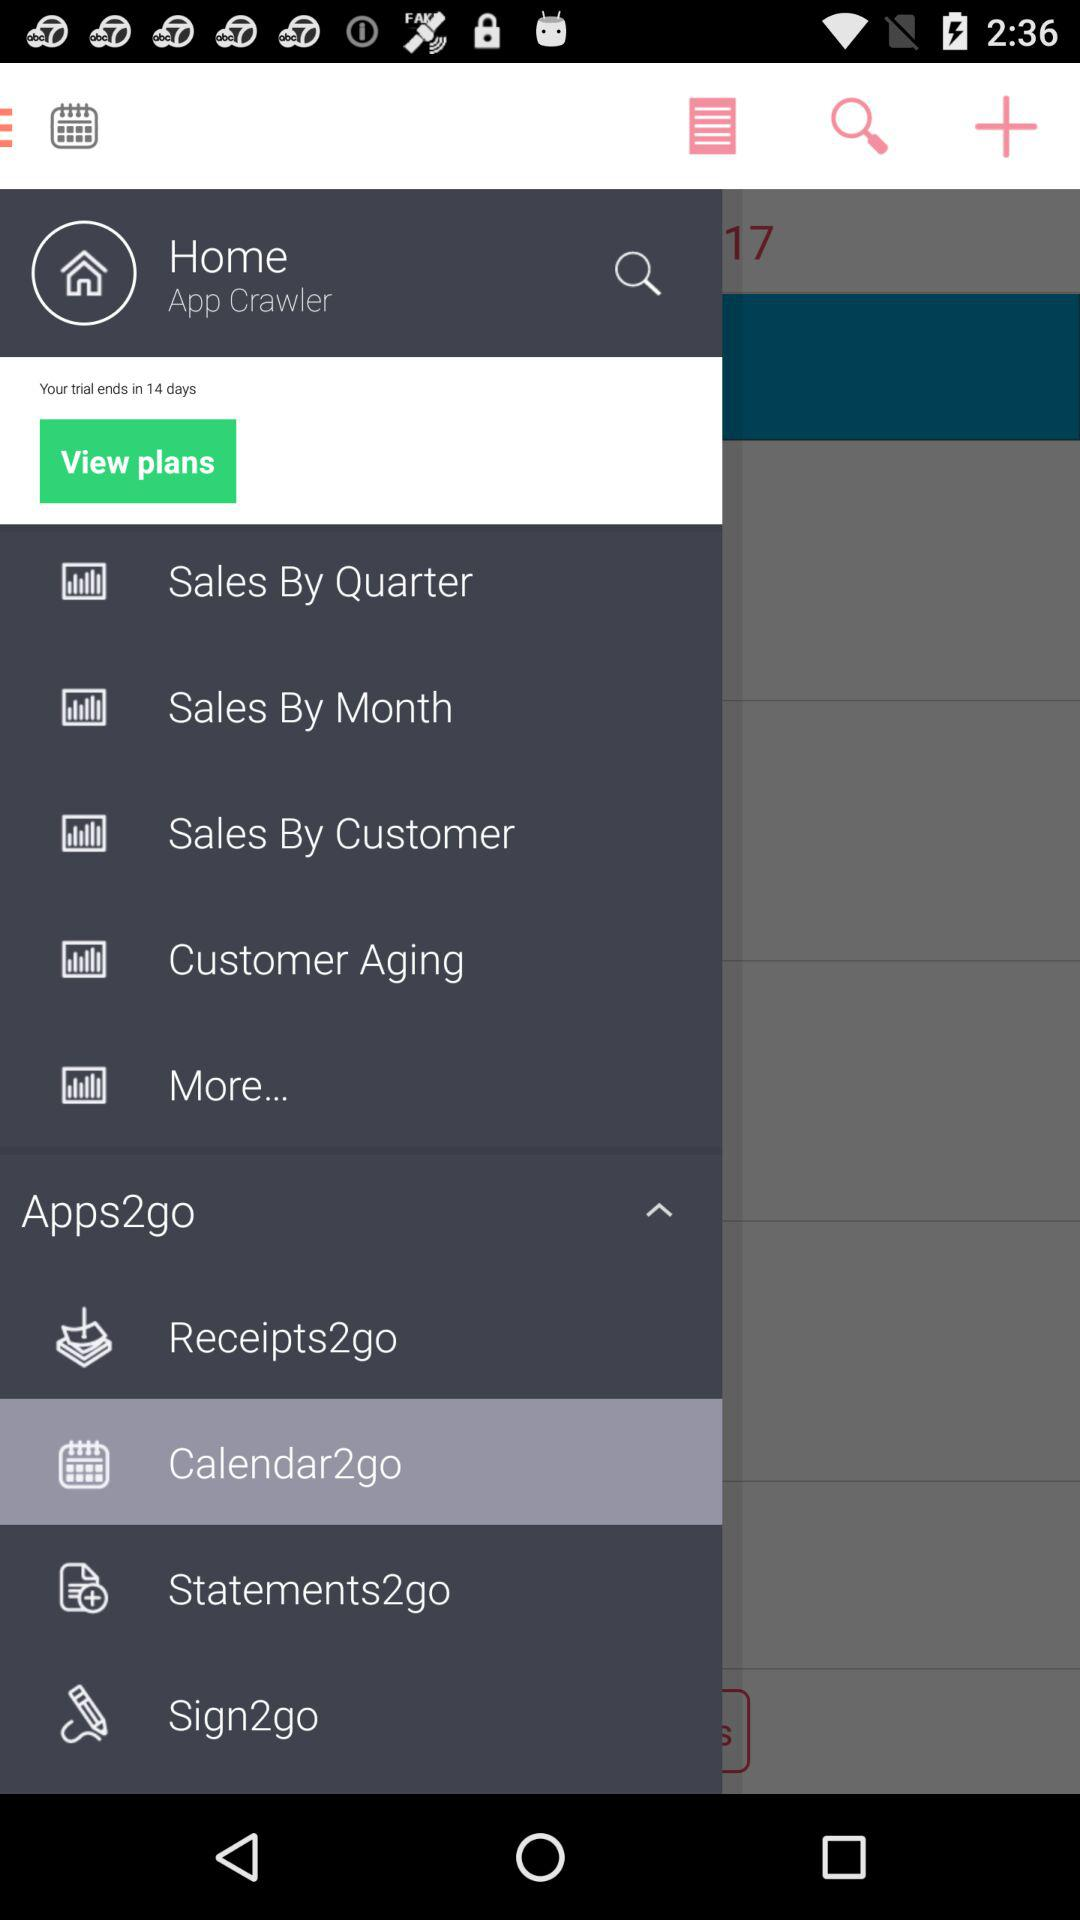In how many days will the trial end? The trial will end in 14 days. 